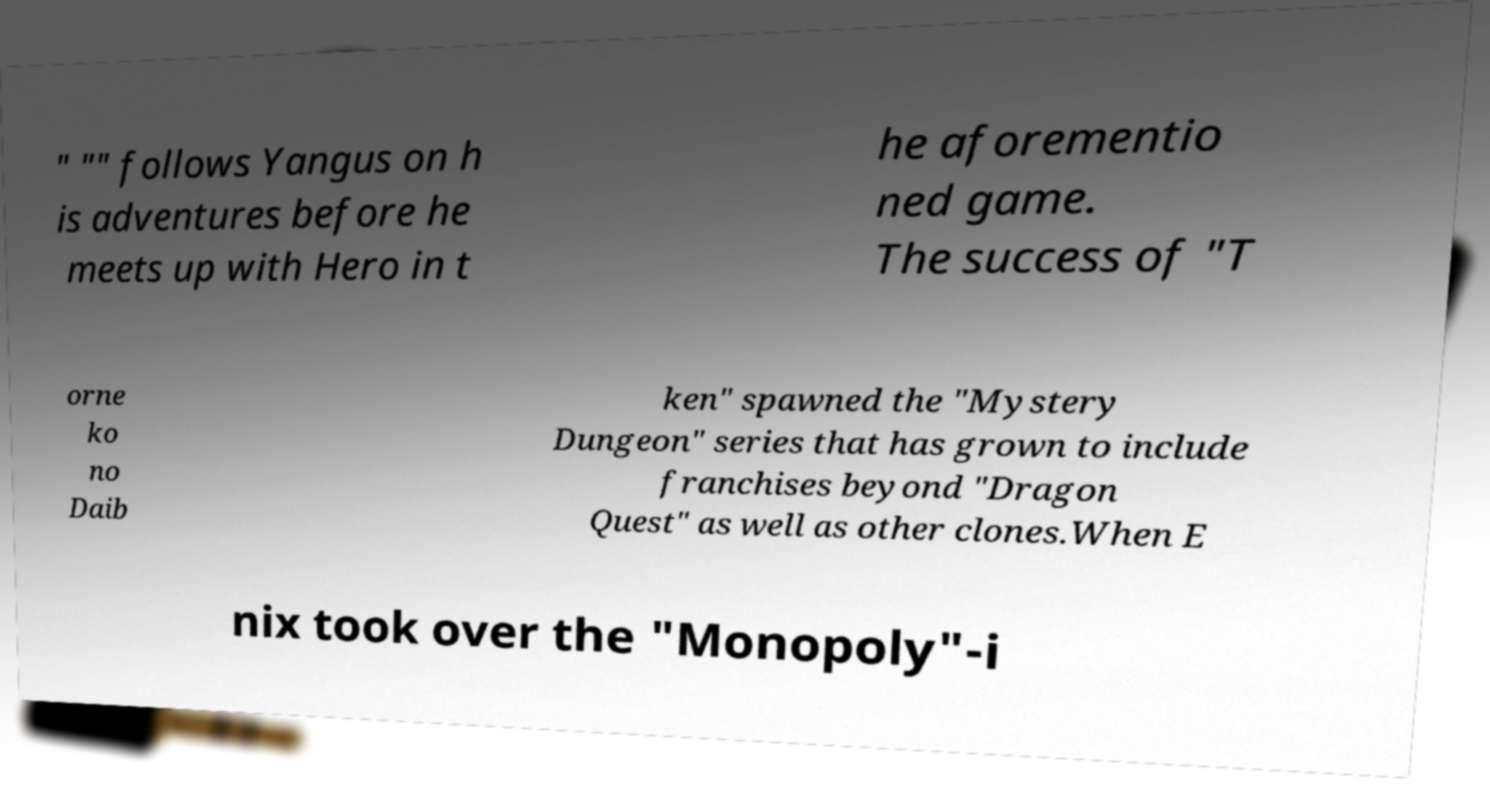Can you accurately transcribe the text from the provided image for me? " "" follows Yangus on h is adventures before he meets up with Hero in t he aforementio ned game. The success of "T orne ko no Daib ken" spawned the "Mystery Dungeon" series that has grown to include franchises beyond "Dragon Quest" as well as other clones.When E nix took over the "Monopoly"-i 